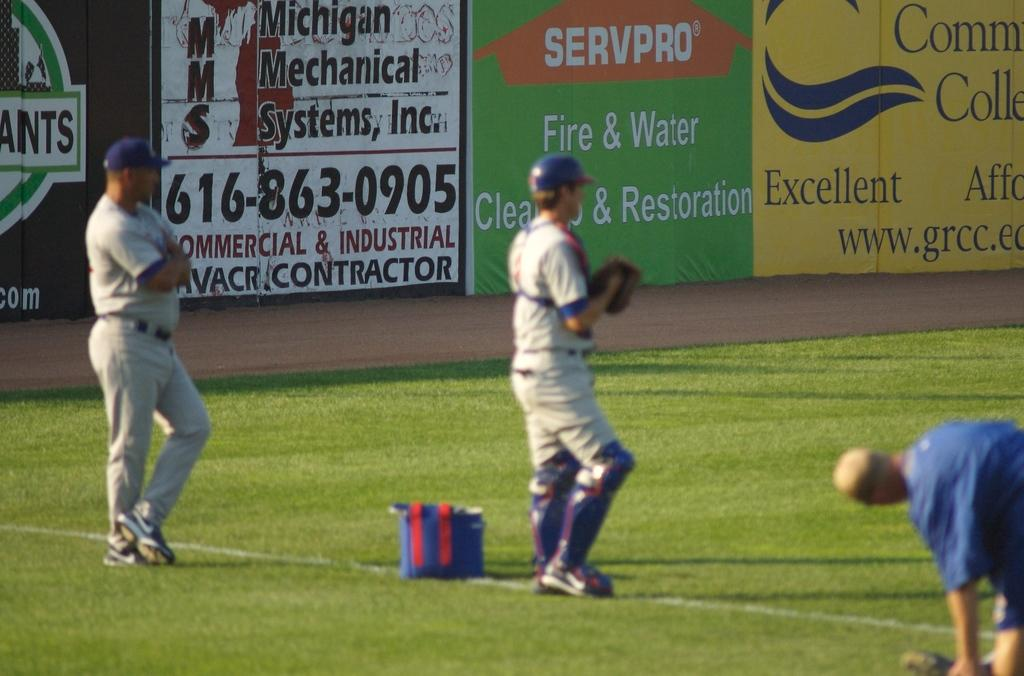Provide a one-sentence caption for the provided image. Players warming up on a baseball field with a sign for Servpro behind them. 